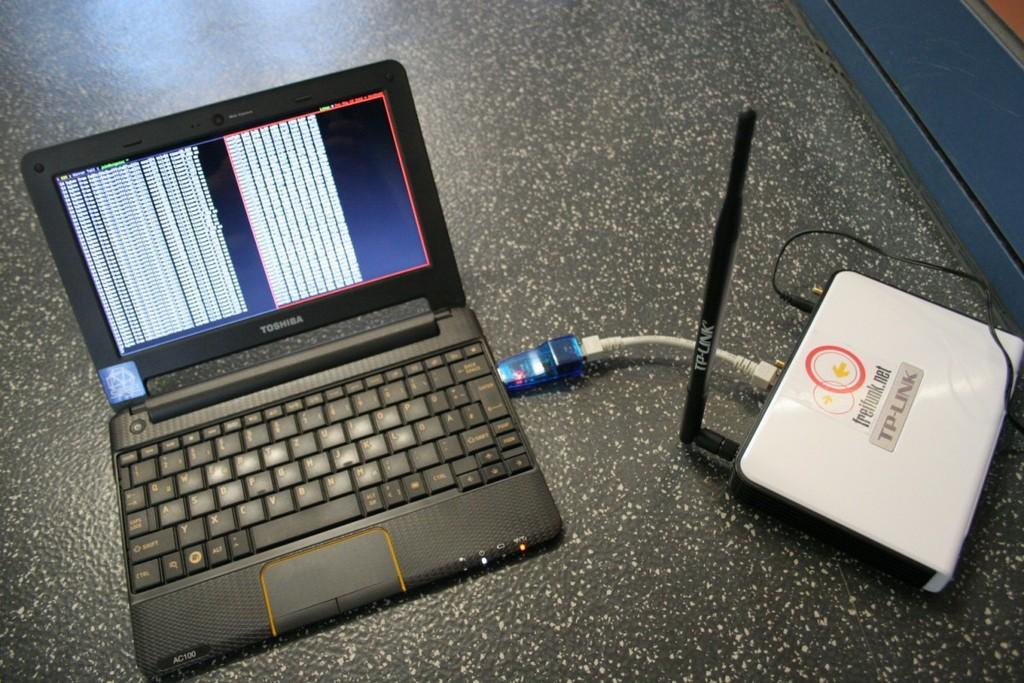Provide a one-sentence caption for the provided image. A laptop hooked up to a device reading TP-Link. 